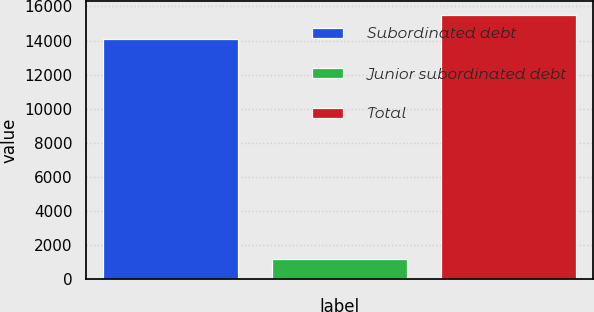Convert chart to OTSL. <chart><loc_0><loc_0><loc_500><loc_500><bar_chart><fcel>Subordinated debt<fcel>Junior subordinated debt<fcel>Total<nl><fcel>14117<fcel>1168<fcel>15528.7<nl></chart> 